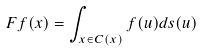Convert formula to latex. <formula><loc_0><loc_0><loc_500><loc_500>F f ( x ) = \int _ { x \in C ( x ) } f ( u ) d s ( u )</formula> 